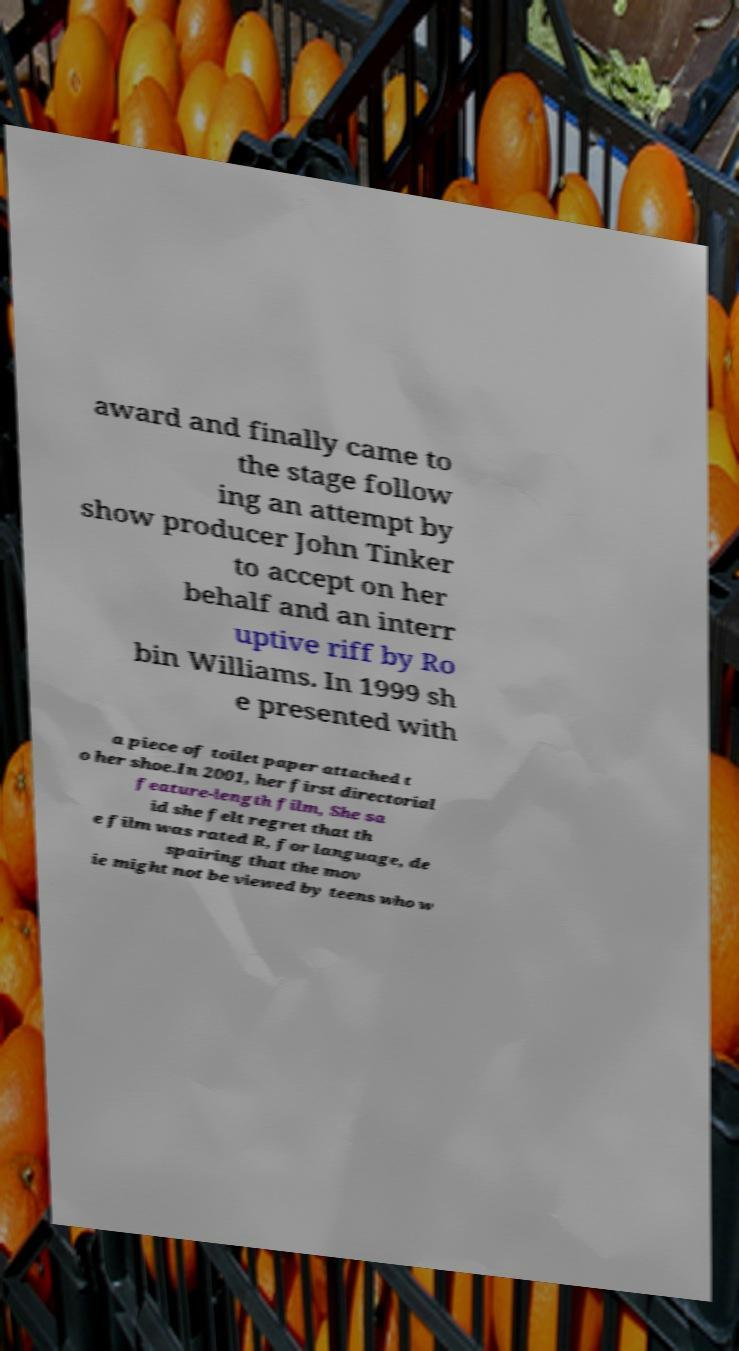Please read and relay the text visible in this image. What does it say? award and finally came to the stage follow ing an attempt by show producer John Tinker to accept on her behalf and an interr uptive riff by Ro bin Williams. In 1999 sh e presented with a piece of toilet paper attached t o her shoe.In 2001, her first directorial feature-length film, She sa id she felt regret that th e film was rated R, for language, de spairing that the mov ie might not be viewed by teens who w 